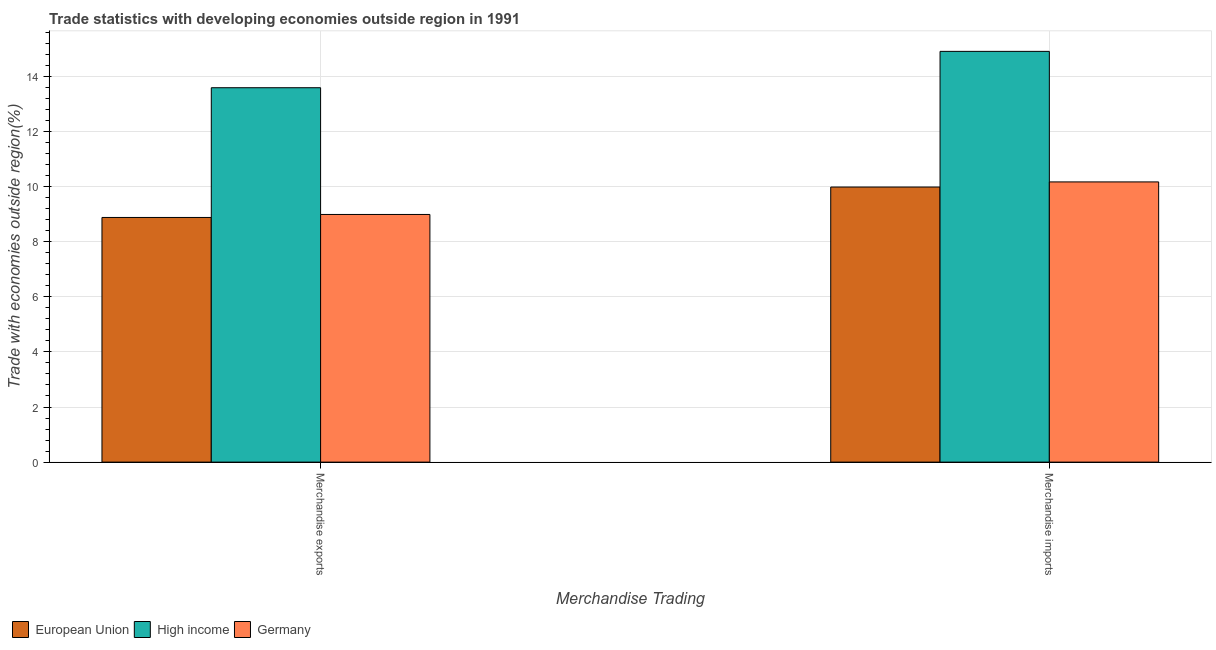How many different coloured bars are there?
Your answer should be compact. 3. Are the number of bars per tick equal to the number of legend labels?
Offer a terse response. Yes. How many bars are there on the 1st tick from the left?
Offer a very short reply. 3. What is the label of the 2nd group of bars from the left?
Give a very brief answer. Merchandise imports. What is the merchandise exports in Germany?
Your answer should be compact. 8.99. Across all countries, what is the maximum merchandise exports?
Provide a short and direct response. 13.59. Across all countries, what is the minimum merchandise imports?
Make the answer very short. 9.98. What is the total merchandise imports in the graph?
Keep it short and to the point. 35.05. What is the difference between the merchandise exports in High income and that in Germany?
Your answer should be very brief. 4.6. What is the difference between the merchandise imports in European Union and the merchandise exports in High income?
Make the answer very short. -3.6. What is the average merchandise imports per country?
Provide a succinct answer. 11.68. What is the difference between the merchandise exports and merchandise imports in High income?
Keep it short and to the point. -1.32. In how many countries, is the merchandise imports greater than 8.4 %?
Provide a short and direct response. 3. What is the ratio of the merchandise exports in High income to that in European Union?
Your response must be concise. 1.53. In how many countries, is the merchandise imports greater than the average merchandise imports taken over all countries?
Provide a succinct answer. 1. What does the 1st bar from the right in Merchandise imports represents?
Offer a terse response. Germany. How many bars are there?
Provide a succinct answer. 6. Are all the bars in the graph horizontal?
Make the answer very short. No. How many countries are there in the graph?
Make the answer very short. 3. What is the difference between two consecutive major ticks on the Y-axis?
Offer a terse response. 2. Does the graph contain any zero values?
Provide a short and direct response. No. How many legend labels are there?
Keep it short and to the point. 3. What is the title of the graph?
Offer a terse response. Trade statistics with developing economies outside region in 1991. Does "High income: nonOECD" appear as one of the legend labels in the graph?
Your answer should be compact. No. What is the label or title of the X-axis?
Offer a terse response. Merchandise Trading. What is the label or title of the Y-axis?
Keep it short and to the point. Trade with economies outside region(%). What is the Trade with economies outside region(%) of European Union in Merchandise exports?
Ensure brevity in your answer.  8.88. What is the Trade with economies outside region(%) of High income in Merchandise exports?
Keep it short and to the point. 13.59. What is the Trade with economies outside region(%) of Germany in Merchandise exports?
Give a very brief answer. 8.99. What is the Trade with economies outside region(%) of European Union in Merchandise imports?
Provide a short and direct response. 9.98. What is the Trade with economies outside region(%) of High income in Merchandise imports?
Give a very brief answer. 14.91. What is the Trade with economies outside region(%) of Germany in Merchandise imports?
Provide a succinct answer. 10.17. Across all Merchandise Trading, what is the maximum Trade with economies outside region(%) of European Union?
Give a very brief answer. 9.98. Across all Merchandise Trading, what is the maximum Trade with economies outside region(%) in High income?
Provide a succinct answer. 14.91. Across all Merchandise Trading, what is the maximum Trade with economies outside region(%) in Germany?
Your answer should be compact. 10.17. Across all Merchandise Trading, what is the minimum Trade with economies outside region(%) of European Union?
Offer a terse response. 8.88. Across all Merchandise Trading, what is the minimum Trade with economies outside region(%) in High income?
Offer a terse response. 13.59. Across all Merchandise Trading, what is the minimum Trade with economies outside region(%) in Germany?
Give a very brief answer. 8.99. What is the total Trade with economies outside region(%) of European Union in the graph?
Your answer should be very brief. 18.86. What is the total Trade with economies outside region(%) of High income in the graph?
Your answer should be very brief. 28.49. What is the total Trade with economies outside region(%) of Germany in the graph?
Give a very brief answer. 19.15. What is the difference between the Trade with economies outside region(%) in European Union in Merchandise exports and that in Merchandise imports?
Your response must be concise. -1.1. What is the difference between the Trade with economies outside region(%) in High income in Merchandise exports and that in Merchandise imports?
Offer a terse response. -1.32. What is the difference between the Trade with economies outside region(%) of Germany in Merchandise exports and that in Merchandise imports?
Your answer should be compact. -1.18. What is the difference between the Trade with economies outside region(%) of European Union in Merchandise exports and the Trade with economies outside region(%) of High income in Merchandise imports?
Your answer should be compact. -6.03. What is the difference between the Trade with economies outside region(%) in European Union in Merchandise exports and the Trade with economies outside region(%) in Germany in Merchandise imports?
Your response must be concise. -1.29. What is the difference between the Trade with economies outside region(%) of High income in Merchandise exports and the Trade with economies outside region(%) of Germany in Merchandise imports?
Your response must be concise. 3.42. What is the average Trade with economies outside region(%) of European Union per Merchandise Trading?
Provide a short and direct response. 9.43. What is the average Trade with economies outside region(%) of High income per Merchandise Trading?
Offer a terse response. 14.25. What is the average Trade with economies outside region(%) of Germany per Merchandise Trading?
Your response must be concise. 9.58. What is the difference between the Trade with economies outside region(%) of European Union and Trade with economies outside region(%) of High income in Merchandise exports?
Provide a short and direct response. -4.71. What is the difference between the Trade with economies outside region(%) of European Union and Trade with economies outside region(%) of Germany in Merchandise exports?
Ensure brevity in your answer.  -0.11. What is the difference between the Trade with economies outside region(%) in High income and Trade with economies outside region(%) in Germany in Merchandise exports?
Give a very brief answer. 4.6. What is the difference between the Trade with economies outside region(%) of European Union and Trade with economies outside region(%) of High income in Merchandise imports?
Provide a succinct answer. -4.92. What is the difference between the Trade with economies outside region(%) of European Union and Trade with economies outside region(%) of Germany in Merchandise imports?
Your answer should be compact. -0.19. What is the difference between the Trade with economies outside region(%) in High income and Trade with economies outside region(%) in Germany in Merchandise imports?
Give a very brief answer. 4.74. What is the ratio of the Trade with economies outside region(%) of European Union in Merchandise exports to that in Merchandise imports?
Offer a very short reply. 0.89. What is the ratio of the Trade with economies outside region(%) of High income in Merchandise exports to that in Merchandise imports?
Your answer should be very brief. 0.91. What is the ratio of the Trade with economies outside region(%) in Germany in Merchandise exports to that in Merchandise imports?
Keep it short and to the point. 0.88. What is the difference between the highest and the second highest Trade with economies outside region(%) in European Union?
Your response must be concise. 1.1. What is the difference between the highest and the second highest Trade with economies outside region(%) in High income?
Give a very brief answer. 1.32. What is the difference between the highest and the second highest Trade with economies outside region(%) in Germany?
Offer a very short reply. 1.18. What is the difference between the highest and the lowest Trade with economies outside region(%) of European Union?
Ensure brevity in your answer.  1.1. What is the difference between the highest and the lowest Trade with economies outside region(%) of High income?
Give a very brief answer. 1.32. What is the difference between the highest and the lowest Trade with economies outside region(%) of Germany?
Your answer should be very brief. 1.18. 